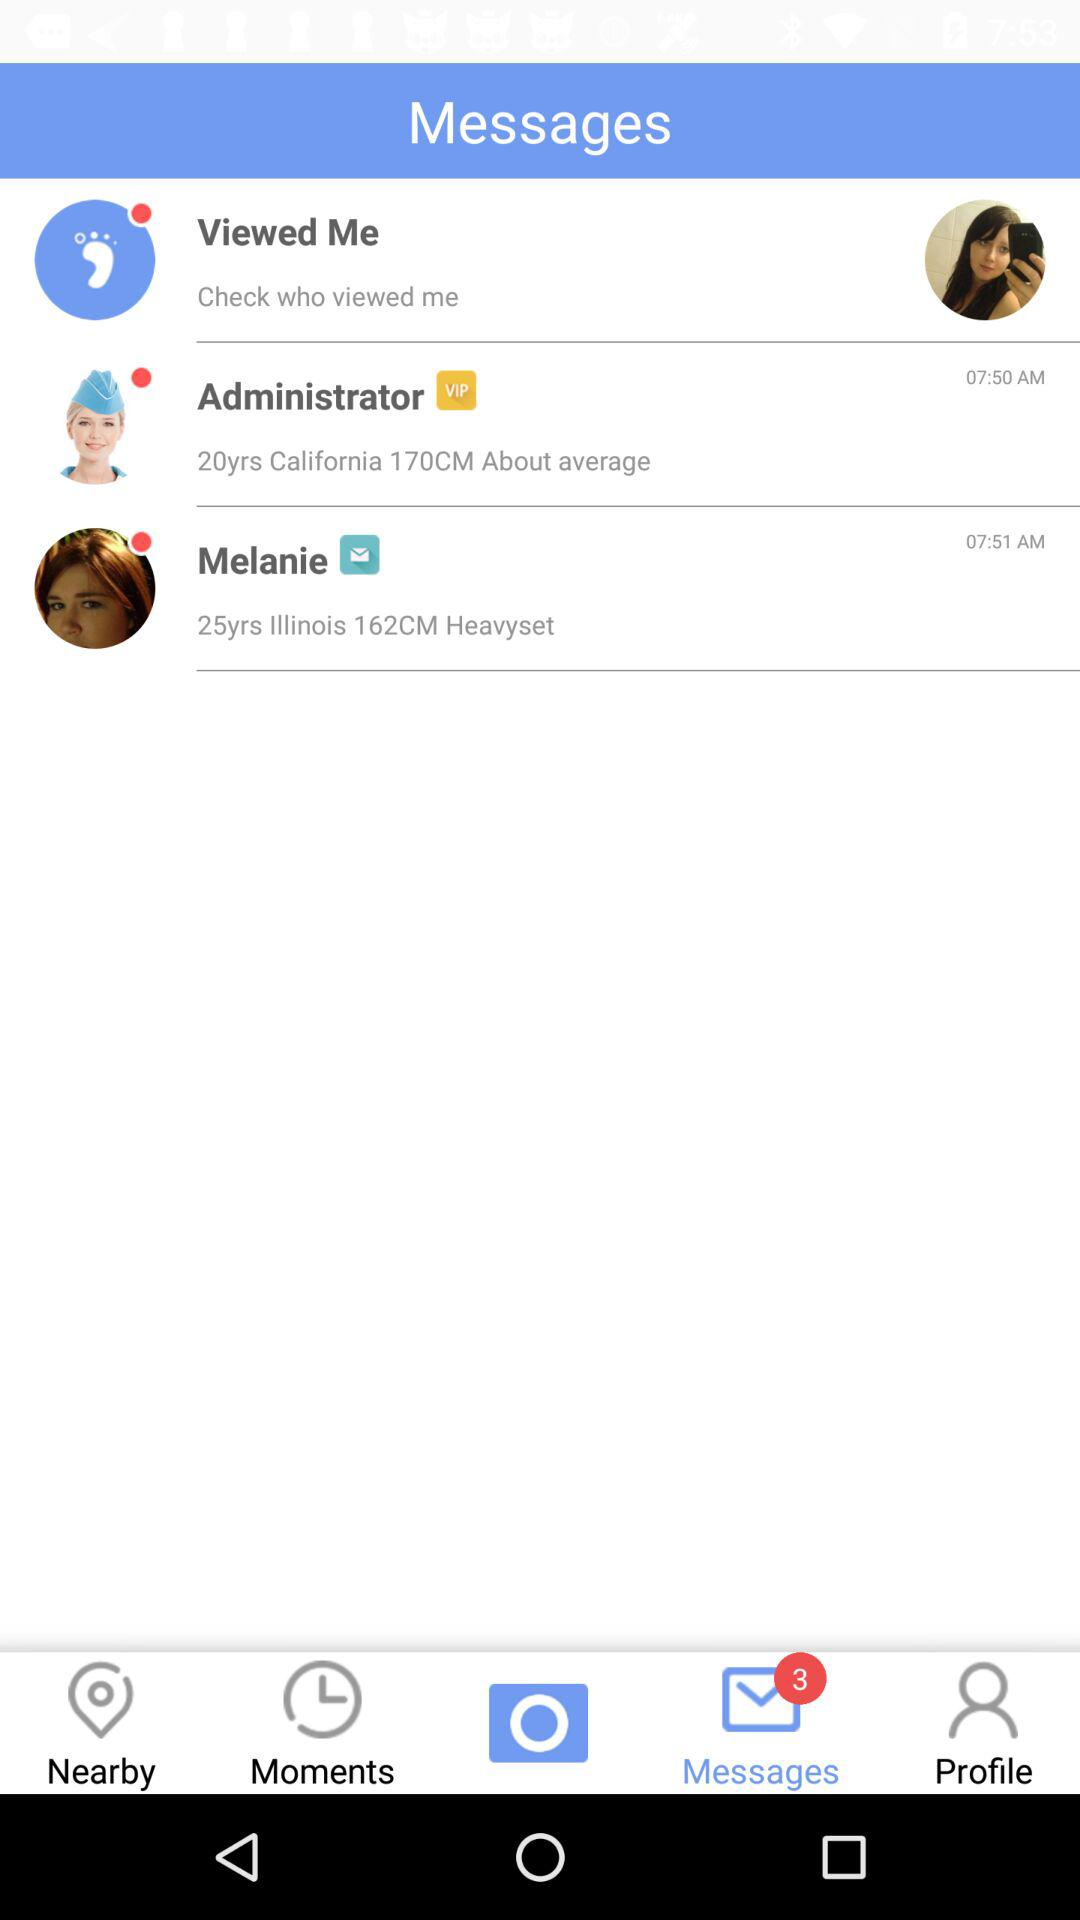What is the selected tab? The selected tab is "Messages". 